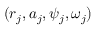<formula> <loc_0><loc_0><loc_500><loc_500>( r _ { j } , a _ { j } , \psi _ { j } , \omega _ { j } )</formula> 